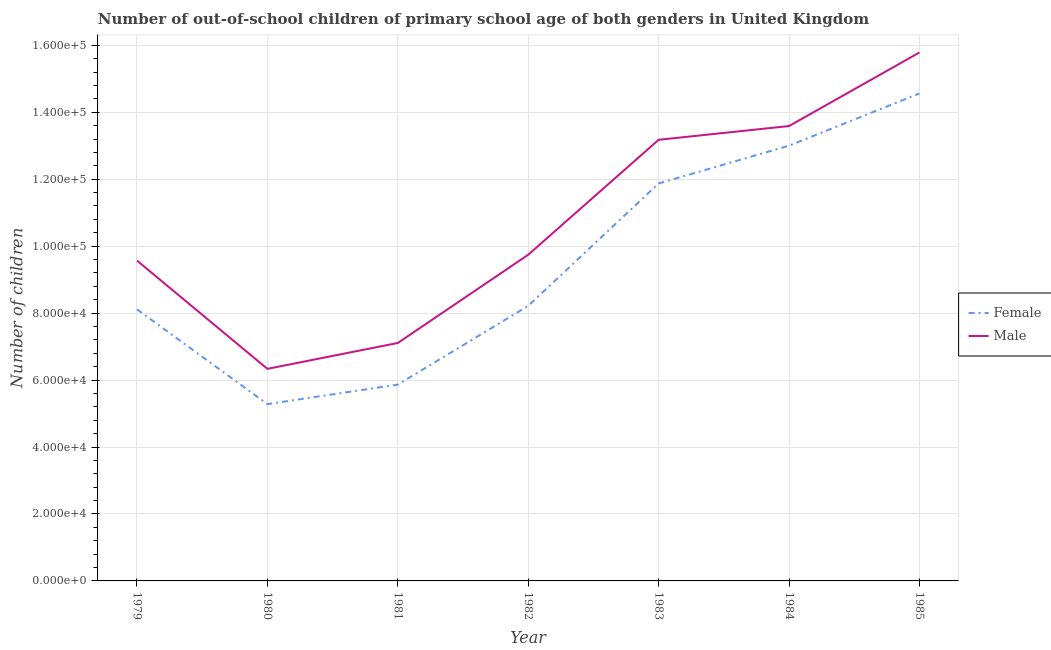Is the number of lines equal to the number of legend labels?
Your answer should be compact. Yes. What is the number of female out-of-school students in 1980?
Keep it short and to the point. 5.28e+04. Across all years, what is the maximum number of male out-of-school students?
Your answer should be very brief. 1.58e+05. Across all years, what is the minimum number of male out-of-school students?
Ensure brevity in your answer.  6.34e+04. In which year was the number of male out-of-school students maximum?
Offer a terse response. 1985. What is the total number of male out-of-school students in the graph?
Make the answer very short. 7.53e+05. What is the difference between the number of male out-of-school students in 1982 and that in 1985?
Provide a succinct answer. -6.04e+04. What is the difference between the number of female out-of-school students in 1979 and the number of male out-of-school students in 1983?
Offer a terse response. -5.06e+04. What is the average number of male out-of-school students per year?
Make the answer very short. 1.08e+05. In the year 1982, what is the difference between the number of male out-of-school students and number of female out-of-school students?
Your answer should be compact. 1.53e+04. In how many years, is the number of female out-of-school students greater than 112000?
Offer a terse response. 3. What is the ratio of the number of female out-of-school students in 1982 to that in 1983?
Give a very brief answer. 0.69. Is the difference between the number of male out-of-school students in 1979 and 1984 greater than the difference between the number of female out-of-school students in 1979 and 1984?
Offer a terse response. Yes. What is the difference between the highest and the second highest number of female out-of-school students?
Keep it short and to the point. 1.56e+04. What is the difference between the highest and the lowest number of female out-of-school students?
Offer a terse response. 9.28e+04. In how many years, is the number of male out-of-school students greater than the average number of male out-of-school students taken over all years?
Offer a very short reply. 3. Is the sum of the number of male out-of-school students in 1982 and 1983 greater than the maximum number of female out-of-school students across all years?
Provide a short and direct response. Yes. Does the number of female out-of-school students monotonically increase over the years?
Offer a terse response. No. Is the number of male out-of-school students strictly less than the number of female out-of-school students over the years?
Provide a short and direct response. No. What is the difference between two consecutive major ticks on the Y-axis?
Your answer should be very brief. 2.00e+04. Does the graph contain grids?
Ensure brevity in your answer.  Yes. Where does the legend appear in the graph?
Your answer should be very brief. Center right. What is the title of the graph?
Your response must be concise. Number of out-of-school children of primary school age of both genders in United Kingdom. Does "Private consumption" appear as one of the legend labels in the graph?
Make the answer very short. No. What is the label or title of the X-axis?
Your answer should be compact. Year. What is the label or title of the Y-axis?
Your answer should be compact. Number of children. What is the Number of children of Female in 1979?
Give a very brief answer. 8.11e+04. What is the Number of children in Male in 1979?
Provide a succinct answer. 9.57e+04. What is the Number of children of Female in 1980?
Make the answer very short. 5.28e+04. What is the Number of children of Male in 1980?
Ensure brevity in your answer.  6.34e+04. What is the Number of children of Female in 1981?
Provide a succinct answer. 5.86e+04. What is the Number of children in Male in 1981?
Offer a very short reply. 7.11e+04. What is the Number of children in Female in 1982?
Ensure brevity in your answer.  8.22e+04. What is the Number of children in Male in 1982?
Your answer should be compact. 9.74e+04. What is the Number of children in Female in 1983?
Your answer should be very brief. 1.19e+05. What is the Number of children in Male in 1983?
Your response must be concise. 1.32e+05. What is the Number of children of Female in 1984?
Provide a succinct answer. 1.30e+05. What is the Number of children in Male in 1984?
Give a very brief answer. 1.36e+05. What is the Number of children of Female in 1985?
Keep it short and to the point. 1.46e+05. What is the Number of children in Male in 1985?
Offer a very short reply. 1.58e+05. Across all years, what is the maximum Number of children in Female?
Give a very brief answer. 1.46e+05. Across all years, what is the maximum Number of children in Male?
Offer a terse response. 1.58e+05. Across all years, what is the minimum Number of children in Female?
Provide a short and direct response. 5.28e+04. Across all years, what is the minimum Number of children of Male?
Your response must be concise. 6.34e+04. What is the total Number of children of Female in the graph?
Keep it short and to the point. 6.69e+05. What is the total Number of children of Male in the graph?
Make the answer very short. 7.53e+05. What is the difference between the Number of children in Female in 1979 and that in 1980?
Keep it short and to the point. 2.83e+04. What is the difference between the Number of children in Male in 1979 and that in 1980?
Give a very brief answer. 3.23e+04. What is the difference between the Number of children in Female in 1979 and that in 1981?
Your response must be concise. 2.25e+04. What is the difference between the Number of children in Male in 1979 and that in 1981?
Make the answer very short. 2.46e+04. What is the difference between the Number of children in Female in 1979 and that in 1982?
Provide a short and direct response. -1040. What is the difference between the Number of children of Male in 1979 and that in 1982?
Your response must be concise. -1754. What is the difference between the Number of children in Female in 1979 and that in 1983?
Provide a short and direct response. -3.76e+04. What is the difference between the Number of children of Male in 1979 and that in 1983?
Provide a succinct answer. -3.61e+04. What is the difference between the Number of children in Female in 1979 and that in 1984?
Ensure brevity in your answer.  -4.89e+04. What is the difference between the Number of children in Male in 1979 and that in 1984?
Ensure brevity in your answer.  -4.02e+04. What is the difference between the Number of children in Female in 1979 and that in 1985?
Your answer should be very brief. -6.45e+04. What is the difference between the Number of children in Male in 1979 and that in 1985?
Your answer should be very brief. -6.22e+04. What is the difference between the Number of children in Female in 1980 and that in 1981?
Keep it short and to the point. -5831. What is the difference between the Number of children in Male in 1980 and that in 1981?
Your answer should be compact. -7732. What is the difference between the Number of children in Female in 1980 and that in 1982?
Ensure brevity in your answer.  -2.94e+04. What is the difference between the Number of children of Male in 1980 and that in 1982?
Ensure brevity in your answer.  -3.41e+04. What is the difference between the Number of children in Female in 1980 and that in 1983?
Your answer should be very brief. -6.59e+04. What is the difference between the Number of children in Male in 1980 and that in 1983?
Offer a very short reply. -6.84e+04. What is the difference between the Number of children in Female in 1980 and that in 1984?
Provide a succinct answer. -7.72e+04. What is the difference between the Number of children in Male in 1980 and that in 1984?
Give a very brief answer. -7.25e+04. What is the difference between the Number of children in Female in 1980 and that in 1985?
Your response must be concise. -9.28e+04. What is the difference between the Number of children in Male in 1980 and that in 1985?
Offer a terse response. -9.45e+04. What is the difference between the Number of children of Female in 1981 and that in 1982?
Ensure brevity in your answer.  -2.35e+04. What is the difference between the Number of children of Male in 1981 and that in 1982?
Provide a succinct answer. -2.64e+04. What is the difference between the Number of children in Female in 1981 and that in 1983?
Your response must be concise. -6.01e+04. What is the difference between the Number of children of Male in 1981 and that in 1983?
Your answer should be compact. -6.07e+04. What is the difference between the Number of children in Female in 1981 and that in 1984?
Your answer should be very brief. -7.14e+04. What is the difference between the Number of children of Male in 1981 and that in 1984?
Your answer should be very brief. -6.48e+04. What is the difference between the Number of children of Female in 1981 and that in 1985?
Give a very brief answer. -8.70e+04. What is the difference between the Number of children of Male in 1981 and that in 1985?
Make the answer very short. -8.68e+04. What is the difference between the Number of children of Female in 1982 and that in 1983?
Your answer should be compact. -3.66e+04. What is the difference between the Number of children in Male in 1982 and that in 1983?
Ensure brevity in your answer.  -3.43e+04. What is the difference between the Number of children in Female in 1982 and that in 1984?
Ensure brevity in your answer.  -4.79e+04. What is the difference between the Number of children in Male in 1982 and that in 1984?
Provide a succinct answer. -3.84e+04. What is the difference between the Number of children of Female in 1982 and that in 1985?
Provide a succinct answer. -6.34e+04. What is the difference between the Number of children in Male in 1982 and that in 1985?
Your response must be concise. -6.04e+04. What is the difference between the Number of children of Female in 1983 and that in 1984?
Your answer should be compact. -1.13e+04. What is the difference between the Number of children in Male in 1983 and that in 1984?
Provide a succinct answer. -4105. What is the difference between the Number of children of Female in 1983 and that in 1985?
Give a very brief answer. -2.69e+04. What is the difference between the Number of children in Male in 1983 and that in 1985?
Provide a succinct answer. -2.61e+04. What is the difference between the Number of children in Female in 1984 and that in 1985?
Your response must be concise. -1.56e+04. What is the difference between the Number of children in Male in 1984 and that in 1985?
Give a very brief answer. -2.20e+04. What is the difference between the Number of children of Female in 1979 and the Number of children of Male in 1980?
Your response must be concise. 1.78e+04. What is the difference between the Number of children in Female in 1979 and the Number of children in Male in 1981?
Provide a short and direct response. 1.00e+04. What is the difference between the Number of children in Female in 1979 and the Number of children in Male in 1982?
Provide a succinct answer. -1.63e+04. What is the difference between the Number of children in Female in 1979 and the Number of children in Male in 1983?
Your response must be concise. -5.06e+04. What is the difference between the Number of children in Female in 1979 and the Number of children in Male in 1984?
Offer a terse response. -5.48e+04. What is the difference between the Number of children in Female in 1979 and the Number of children in Male in 1985?
Provide a short and direct response. -7.67e+04. What is the difference between the Number of children in Female in 1980 and the Number of children in Male in 1981?
Your response must be concise. -1.83e+04. What is the difference between the Number of children in Female in 1980 and the Number of children in Male in 1982?
Give a very brief answer. -4.46e+04. What is the difference between the Number of children in Female in 1980 and the Number of children in Male in 1983?
Your answer should be compact. -7.90e+04. What is the difference between the Number of children in Female in 1980 and the Number of children in Male in 1984?
Ensure brevity in your answer.  -8.31e+04. What is the difference between the Number of children of Female in 1980 and the Number of children of Male in 1985?
Offer a very short reply. -1.05e+05. What is the difference between the Number of children in Female in 1981 and the Number of children in Male in 1982?
Provide a short and direct response. -3.88e+04. What is the difference between the Number of children in Female in 1981 and the Number of children in Male in 1983?
Give a very brief answer. -7.31e+04. What is the difference between the Number of children in Female in 1981 and the Number of children in Male in 1984?
Your answer should be very brief. -7.72e+04. What is the difference between the Number of children of Female in 1981 and the Number of children of Male in 1985?
Make the answer very short. -9.92e+04. What is the difference between the Number of children of Female in 1982 and the Number of children of Male in 1983?
Provide a succinct answer. -4.96e+04. What is the difference between the Number of children in Female in 1982 and the Number of children in Male in 1984?
Offer a very short reply. -5.37e+04. What is the difference between the Number of children in Female in 1982 and the Number of children in Male in 1985?
Offer a very short reply. -7.57e+04. What is the difference between the Number of children of Female in 1983 and the Number of children of Male in 1984?
Your answer should be compact. -1.71e+04. What is the difference between the Number of children of Female in 1983 and the Number of children of Male in 1985?
Your answer should be compact. -3.91e+04. What is the difference between the Number of children in Female in 1984 and the Number of children in Male in 1985?
Offer a terse response. -2.78e+04. What is the average Number of children of Female per year?
Provide a succinct answer. 9.56e+04. What is the average Number of children in Male per year?
Offer a terse response. 1.08e+05. In the year 1979, what is the difference between the Number of children in Female and Number of children in Male?
Offer a very short reply. -1.46e+04. In the year 1980, what is the difference between the Number of children in Female and Number of children in Male?
Make the answer very short. -1.05e+04. In the year 1981, what is the difference between the Number of children of Female and Number of children of Male?
Offer a very short reply. -1.24e+04. In the year 1982, what is the difference between the Number of children in Female and Number of children in Male?
Your response must be concise. -1.53e+04. In the year 1983, what is the difference between the Number of children of Female and Number of children of Male?
Ensure brevity in your answer.  -1.30e+04. In the year 1984, what is the difference between the Number of children of Female and Number of children of Male?
Give a very brief answer. -5857. In the year 1985, what is the difference between the Number of children in Female and Number of children in Male?
Your answer should be compact. -1.22e+04. What is the ratio of the Number of children in Female in 1979 to that in 1980?
Your answer should be very brief. 1.54. What is the ratio of the Number of children of Male in 1979 to that in 1980?
Ensure brevity in your answer.  1.51. What is the ratio of the Number of children in Female in 1979 to that in 1981?
Ensure brevity in your answer.  1.38. What is the ratio of the Number of children in Male in 1979 to that in 1981?
Your response must be concise. 1.35. What is the ratio of the Number of children in Female in 1979 to that in 1982?
Your answer should be very brief. 0.99. What is the ratio of the Number of children of Female in 1979 to that in 1983?
Offer a very short reply. 0.68. What is the ratio of the Number of children in Male in 1979 to that in 1983?
Offer a terse response. 0.73. What is the ratio of the Number of children in Female in 1979 to that in 1984?
Make the answer very short. 0.62. What is the ratio of the Number of children of Male in 1979 to that in 1984?
Provide a short and direct response. 0.7. What is the ratio of the Number of children of Female in 1979 to that in 1985?
Provide a succinct answer. 0.56. What is the ratio of the Number of children of Male in 1979 to that in 1985?
Your answer should be compact. 0.61. What is the ratio of the Number of children of Female in 1980 to that in 1981?
Make the answer very short. 0.9. What is the ratio of the Number of children in Male in 1980 to that in 1981?
Give a very brief answer. 0.89. What is the ratio of the Number of children in Female in 1980 to that in 1982?
Your response must be concise. 0.64. What is the ratio of the Number of children of Male in 1980 to that in 1982?
Your response must be concise. 0.65. What is the ratio of the Number of children of Female in 1980 to that in 1983?
Give a very brief answer. 0.44. What is the ratio of the Number of children of Male in 1980 to that in 1983?
Give a very brief answer. 0.48. What is the ratio of the Number of children of Female in 1980 to that in 1984?
Your response must be concise. 0.41. What is the ratio of the Number of children in Male in 1980 to that in 1984?
Provide a succinct answer. 0.47. What is the ratio of the Number of children of Female in 1980 to that in 1985?
Provide a short and direct response. 0.36. What is the ratio of the Number of children of Male in 1980 to that in 1985?
Give a very brief answer. 0.4. What is the ratio of the Number of children in Female in 1981 to that in 1982?
Your answer should be very brief. 0.71. What is the ratio of the Number of children of Male in 1981 to that in 1982?
Ensure brevity in your answer.  0.73. What is the ratio of the Number of children in Female in 1981 to that in 1983?
Your response must be concise. 0.49. What is the ratio of the Number of children in Male in 1981 to that in 1983?
Keep it short and to the point. 0.54. What is the ratio of the Number of children in Female in 1981 to that in 1984?
Provide a succinct answer. 0.45. What is the ratio of the Number of children of Male in 1981 to that in 1984?
Your response must be concise. 0.52. What is the ratio of the Number of children of Female in 1981 to that in 1985?
Provide a succinct answer. 0.4. What is the ratio of the Number of children of Male in 1981 to that in 1985?
Provide a short and direct response. 0.45. What is the ratio of the Number of children of Female in 1982 to that in 1983?
Provide a succinct answer. 0.69. What is the ratio of the Number of children of Male in 1982 to that in 1983?
Your answer should be very brief. 0.74. What is the ratio of the Number of children in Female in 1982 to that in 1984?
Offer a very short reply. 0.63. What is the ratio of the Number of children of Male in 1982 to that in 1984?
Provide a succinct answer. 0.72. What is the ratio of the Number of children of Female in 1982 to that in 1985?
Your answer should be compact. 0.56. What is the ratio of the Number of children in Male in 1982 to that in 1985?
Offer a very short reply. 0.62. What is the ratio of the Number of children in Female in 1983 to that in 1984?
Provide a succinct answer. 0.91. What is the ratio of the Number of children in Male in 1983 to that in 1984?
Give a very brief answer. 0.97. What is the ratio of the Number of children of Female in 1983 to that in 1985?
Your response must be concise. 0.82. What is the ratio of the Number of children in Male in 1983 to that in 1985?
Offer a very short reply. 0.83. What is the ratio of the Number of children of Female in 1984 to that in 1985?
Make the answer very short. 0.89. What is the ratio of the Number of children in Male in 1984 to that in 1985?
Make the answer very short. 0.86. What is the difference between the highest and the second highest Number of children in Female?
Provide a succinct answer. 1.56e+04. What is the difference between the highest and the second highest Number of children in Male?
Provide a short and direct response. 2.20e+04. What is the difference between the highest and the lowest Number of children of Female?
Keep it short and to the point. 9.28e+04. What is the difference between the highest and the lowest Number of children of Male?
Give a very brief answer. 9.45e+04. 